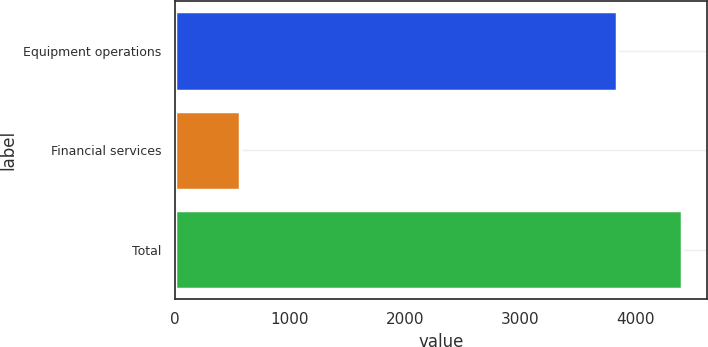Convert chart. <chart><loc_0><loc_0><loc_500><loc_500><bar_chart><fcel>Equipment operations<fcel>Financial services<fcel>Total<nl><fcel>3836<fcel>566<fcel>4402<nl></chart> 